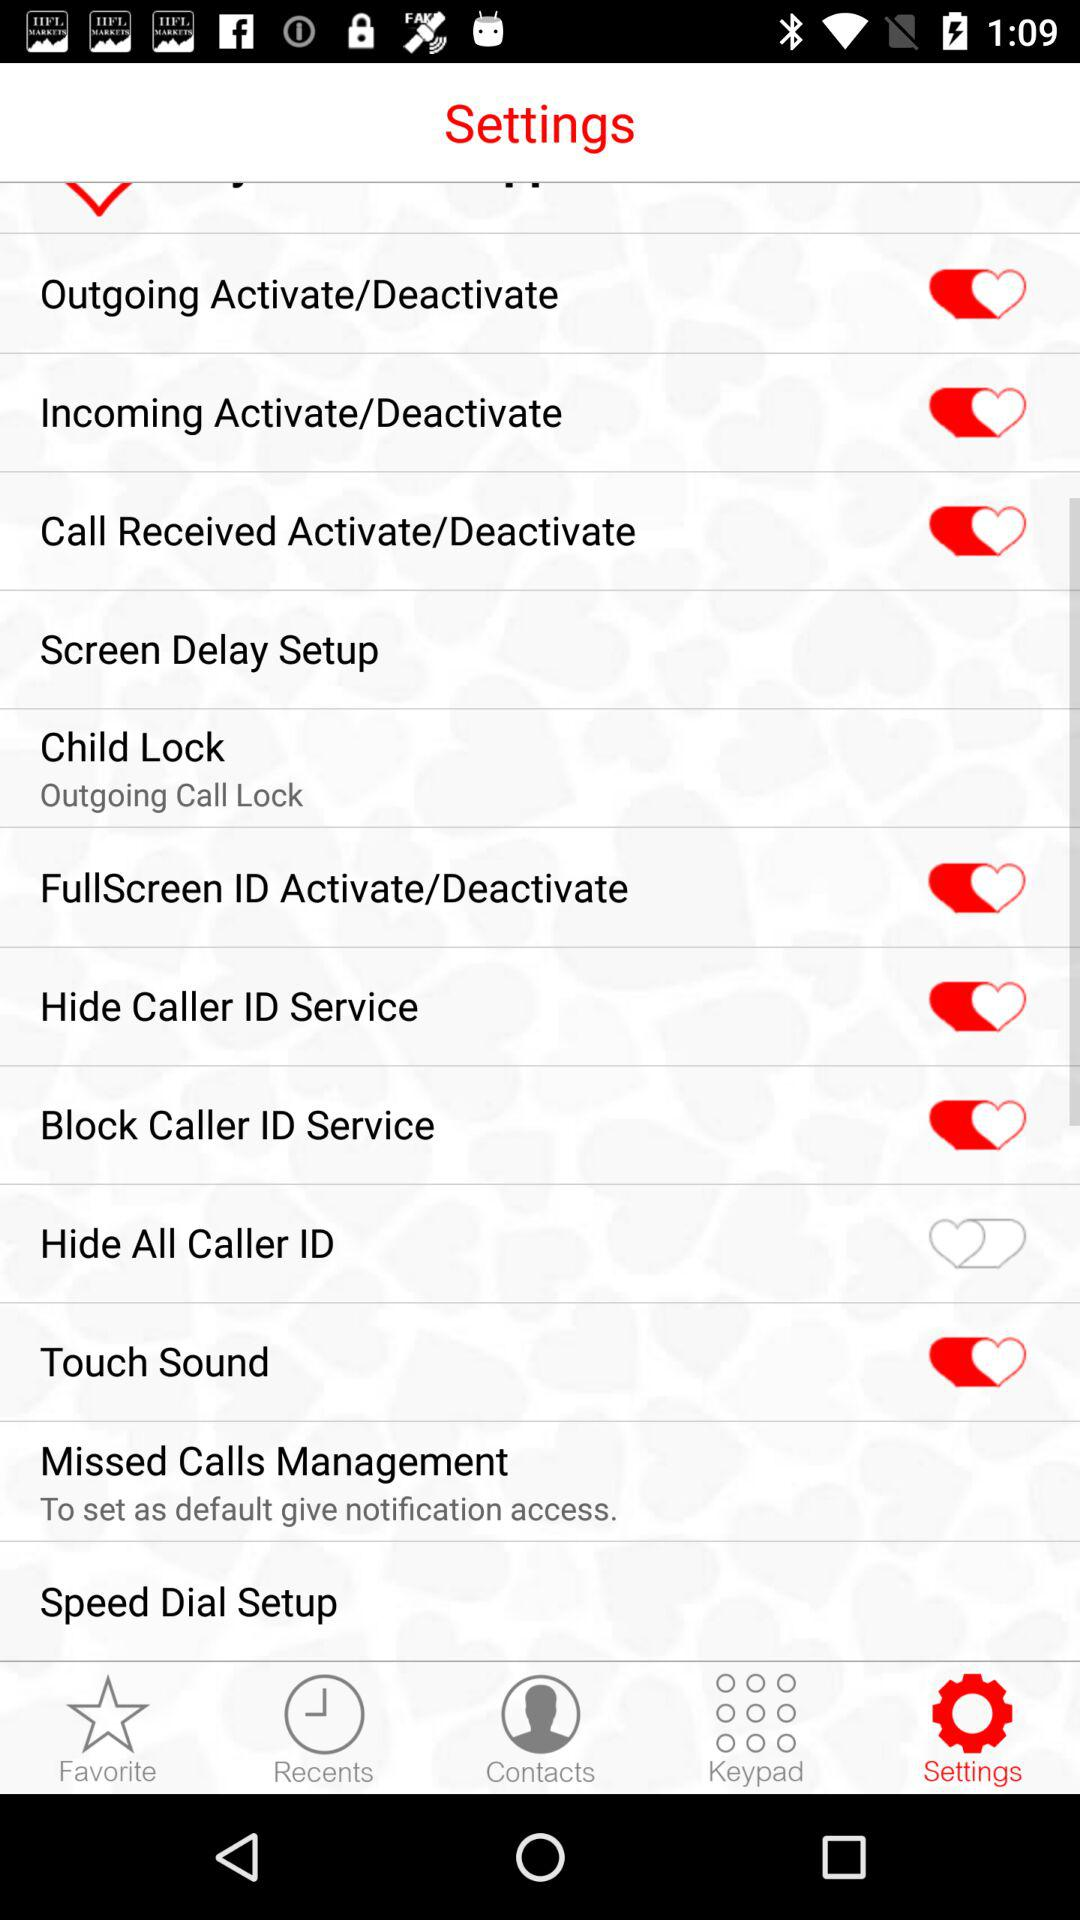What is the status of "Outgoing Activate/Deactivate"? The status is "on". 